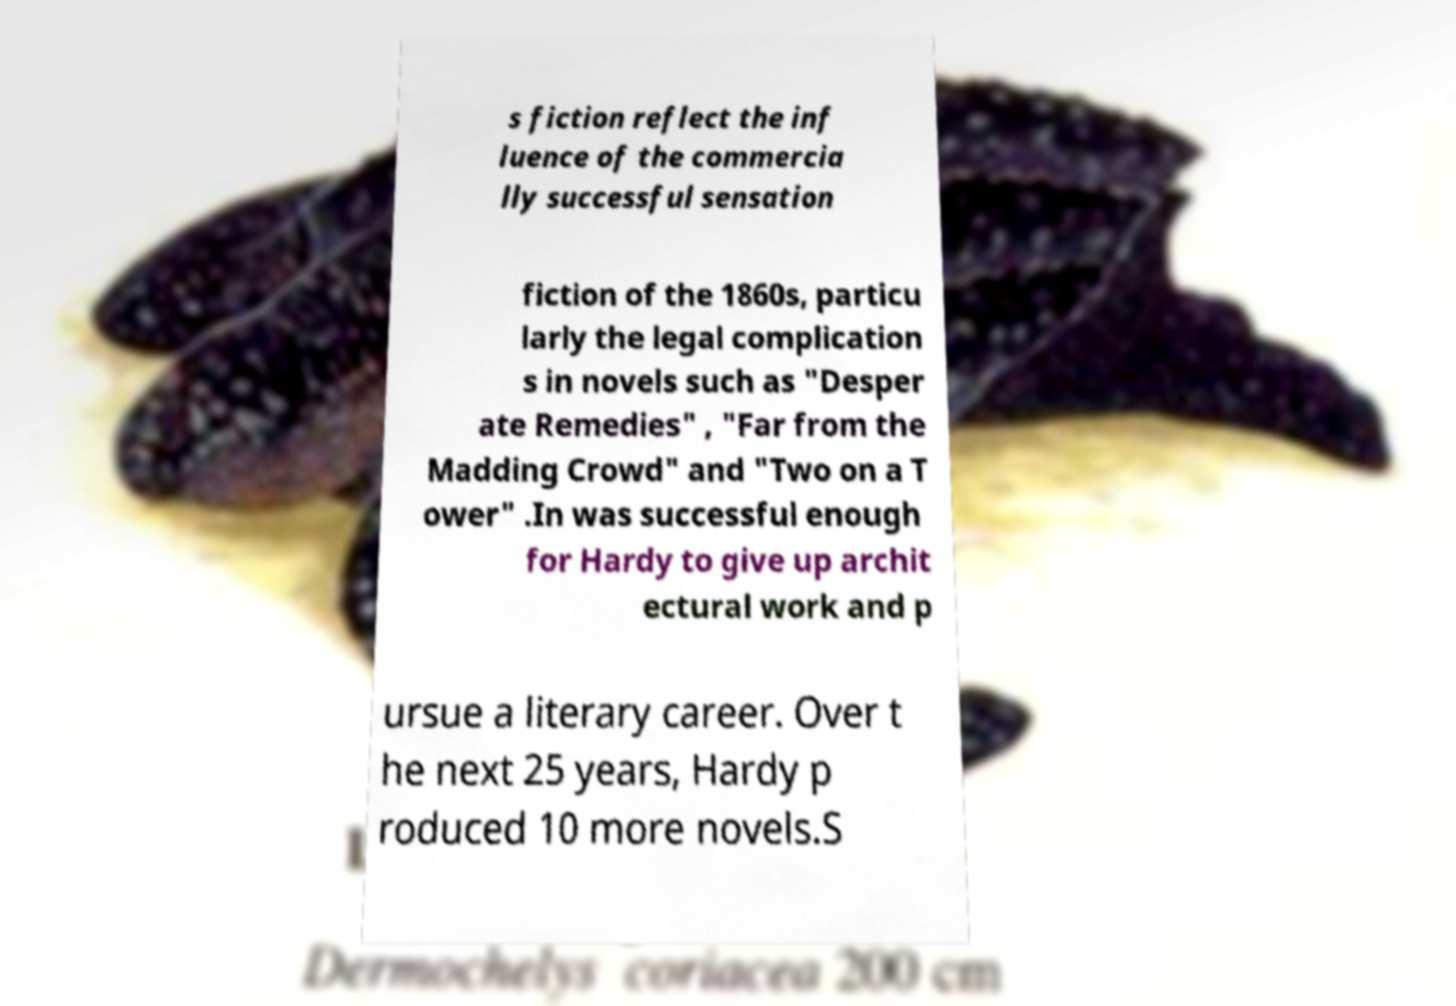For documentation purposes, I need the text within this image transcribed. Could you provide that? s fiction reflect the inf luence of the commercia lly successful sensation fiction of the 1860s, particu larly the legal complication s in novels such as "Desper ate Remedies" , "Far from the Madding Crowd" and "Two on a T ower" .In was successful enough for Hardy to give up archit ectural work and p ursue a literary career. Over t he next 25 years, Hardy p roduced 10 more novels.S 